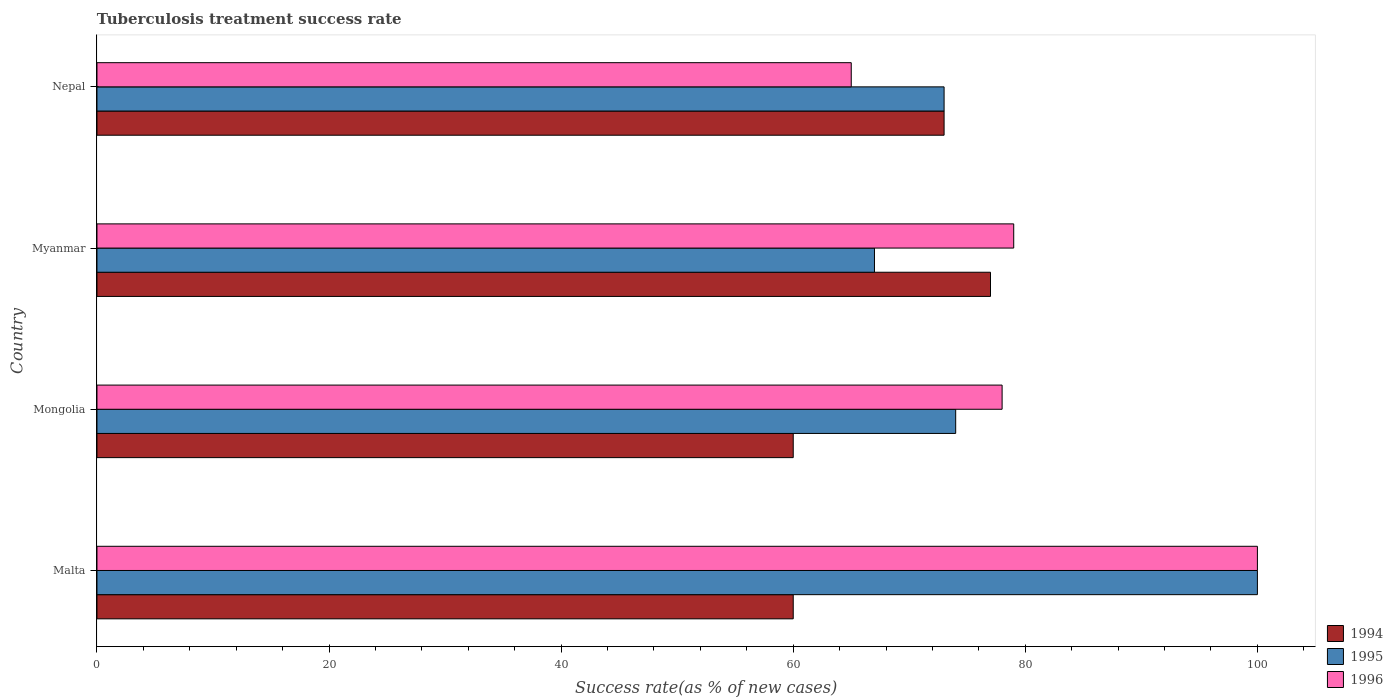How many groups of bars are there?
Give a very brief answer. 4. Are the number of bars per tick equal to the number of legend labels?
Your answer should be very brief. Yes. Are the number of bars on each tick of the Y-axis equal?
Your response must be concise. Yes. How many bars are there on the 1st tick from the bottom?
Offer a terse response. 3. What is the label of the 4th group of bars from the top?
Ensure brevity in your answer.  Malta. Across all countries, what is the minimum tuberculosis treatment success rate in 1995?
Your response must be concise. 67. In which country was the tuberculosis treatment success rate in 1994 maximum?
Ensure brevity in your answer.  Myanmar. In which country was the tuberculosis treatment success rate in 1996 minimum?
Your answer should be compact. Nepal. What is the total tuberculosis treatment success rate in 1996 in the graph?
Your answer should be compact. 322. What is the difference between the tuberculosis treatment success rate in 1995 in Myanmar and that in Nepal?
Keep it short and to the point. -6. What is the difference between the tuberculosis treatment success rate in 1996 in Mongolia and the tuberculosis treatment success rate in 1995 in Malta?
Offer a very short reply. -22. What is the average tuberculosis treatment success rate in 1995 per country?
Your response must be concise. 78.5. In how many countries, is the tuberculosis treatment success rate in 1996 greater than 80 %?
Offer a very short reply. 1. What is the ratio of the tuberculosis treatment success rate in 1995 in Mongolia to that in Nepal?
Offer a terse response. 1.01. In how many countries, is the tuberculosis treatment success rate in 1994 greater than the average tuberculosis treatment success rate in 1994 taken over all countries?
Offer a very short reply. 2. What does the 1st bar from the top in Mongolia represents?
Provide a succinct answer. 1996. How many bars are there?
Offer a very short reply. 12. Are all the bars in the graph horizontal?
Keep it short and to the point. Yes. Are the values on the major ticks of X-axis written in scientific E-notation?
Offer a terse response. No. Does the graph contain any zero values?
Offer a very short reply. No. Does the graph contain grids?
Your answer should be very brief. No. What is the title of the graph?
Provide a succinct answer. Tuberculosis treatment success rate. What is the label or title of the X-axis?
Your answer should be very brief. Success rate(as % of new cases). What is the Success rate(as % of new cases) of 1994 in Malta?
Give a very brief answer. 60. What is the Success rate(as % of new cases) of 1996 in Malta?
Ensure brevity in your answer.  100. What is the Success rate(as % of new cases) of 1994 in Mongolia?
Provide a short and direct response. 60. What is the Success rate(as % of new cases) in 1995 in Mongolia?
Your answer should be compact. 74. What is the Success rate(as % of new cases) of 1994 in Myanmar?
Your answer should be compact. 77. What is the Success rate(as % of new cases) of 1996 in Myanmar?
Your response must be concise. 79. What is the Success rate(as % of new cases) of 1995 in Nepal?
Give a very brief answer. 73. What is the Success rate(as % of new cases) of 1996 in Nepal?
Offer a very short reply. 65. Across all countries, what is the maximum Success rate(as % of new cases) of 1994?
Offer a very short reply. 77. Across all countries, what is the maximum Success rate(as % of new cases) of 1996?
Your answer should be compact. 100. Across all countries, what is the minimum Success rate(as % of new cases) of 1994?
Ensure brevity in your answer.  60. Across all countries, what is the minimum Success rate(as % of new cases) in 1996?
Provide a succinct answer. 65. What is the total Success rate(as % of new cases) of 1994 in the graph?
Provide a succinct answer. 270. What is the total Success rate(as % of new cases) of 1995 in the graph?
Give a very brief answer. 314. What is the total Success rate(as % of new cases) of 1996 in the graph?
Your answer should be compact. 322. What is the difference between the Success rate(as % of new cases) in 1994 in Malta and that in Mongolia?
Your answer should be very brief. 0. What is the difference between the Success rate(as % of new cases) of 1995 in Malta and that in Mongolia?
Provide a succinct answer. 26. What is the difference between the Success rate(as % of new cases) of 1994 in Malta and that in Myanmar?
Offer a very short reply. -17. What is the difference between the Success rate(as % of new cases) in 1995 in Malta and that in Myanmar?
Your answer should be very brief. 33. What is the difference between the Success rate(as % of new cases) of 1994 in Malta and that in Nepal?
Offer a terse response. -13. What is the difference between the Success rate(as % of new cases) in 1994 in Mongolia and that in Myanmar?
Your answer should be very brief. -17. What is the difference between the Success rate(as % of new cases) in 1995 in Mongolia and that in Myanmar?
Provide a short and direct response. 7. What is the difference between the Success rate(as % of new cases) in 1996 in Mongolia and that in Nepal?
Your response must be concise. 13. What is the difference between the Success rate(as % of new cases) of 1994 in Myanmar and that in Nepal?
Make the answer very short. 4. What is the difference between the Success rate(as % of new cases) in 1996 in Myanmar and that in Nepal?
Your answer should be compact. 14. What is the difference between the Success rate(as % of new cases) in 1994 in Malta and the Success rate(as % of new cases) in 1996 in Mongolia?
Your response must be concise. -18. What is the difference between the Success rate(as % of new cases) in 1994 in Malta and the Success rate(as % of new cases) in 1996 in Myanmar?
Ensure brevity in your answer.  -19. What is the difference between the Success rate(as % of new cases) in 1995 in Malta and the Success rate(as % of new cases) in 1996 in Myanmar?
Provide a short and direct response. 21. What is the difference between the Success rate(as % of new cases) in 1994 in Malta and the Success rate(as % of new cases) in 1996 in Nepal?
Ensure brevity in your answer.  -5. What is the difference between the Success rate(as % of new cases) of 1995 in Malta and the Success rate(as % of new cases) of 1996 in Nepal?
Offer a terse response. 35. What is the difference between the Success rate(as % of new cases) in 1994 in Mongolia and the Success rate(as % of new cases) in 1996 in Myanmar?
Keep it short and to the point. -19. What is the difference between the Success rate(as % of new cases) of 1994 in Mongolia and the Success rate(as % of new cases) of 1995 in Nepal?
Give a very brief answer. -13. What is the difference between the Success rate(as % of new cases) of 1995 in Mongolia and the Success rate(as % of new cases) of 1996 in Nepal?
Provide a succinct answer. 9. What is the difference between the Success rate(as % of new cases) in 1995 in Myanmar and the Success rate(as % of new cases) in 1996 in Nepal?
Your answer should be compact. 2. What is the average Success rate(as % of new cases) in 1994 per country?
Your answer should be very brief. 67.5. What is the average Success rate(as % of new cases) in 1995 per country?
Offer a terse response. 78.5. What is the average Success rate(as % of new cases) of 1996 per country?
Your response must be concise. 80.5. What is the difference between the Success rate(as % of new cases) in 1994 and Success rate(as % of new cases) in 1995 in Malta?
Offer a terse response. -40. What is the difference between the Success rate(as % of new cases) of 1994 and Success rate(as % of new cases) of 1996 in Malta?
Your answer should be compact. -40. What is the difference between the Success rate(as % of new cases) of 1995 and Success rate(as % of new cases) of 1996 in Malta?
Keep it short and to the point. 0. What is the difference between the Success rate(as % of new cases) of 1994 and Success rate(as % of new cases) of 1995 in Mongolia?
Make the answer very short. -14. What is the difference between the Success rate(as % of new cases) of 1995 and Success rate(as % of new cases) of 1996 in Mongolia?
Offer a very short reply. -4. What is the difference between the Success rate(as % of new cases) of 1994 and Success rate(as % of new cases) of 1995 in Myanmar?
Give a very brief answer. 10. What is the difference between the Success rate(as % of new cases) in 1994 and Success rate(as % of new cases) in 1996 in Myanmar?
Keep it short and to the point. -2. What is the difference between the Success rate(as % of new cases) in 1994 and Success rate(as % of new cases) in 1995 in Nepal?
Provide a short and direct response. 0. What is the difference between the Success rate(as % of new cases) of 1994 and Success rate(as % of new cases) of 1996 in Nepal?
Provide a short and direct response. 8. What is the difference between the Success rate(as % of new cases) in 1995 and Success rate(as % of new cases) in 1996 in Nepal?
Ensure brevity in your answer.  8. What is the ratio of the Success rate(as % of new cases) in 1995 in Malta to that in Mongolia?
Provide a short and direct response. 1.35. What is the ratio of the Success rate(as % of new cases) in 1996 in Malta to that in Mongolia?
Provide a short and direct response. 1.28. What is the ratio of the Success rate(as % of new cases) of 1994 in Malta to that in Myanmar?
Offer a terse response. 0.78. What is the ratio of the Success rate(as % of new cases) in 1995 in Malta to that in Myanmar?
Your answer should be compact. 1.49. What is the ratio of the Success rate(as % of new cases) in 1996 in Malta to that in Myanmar?
Offer a terse response. 1.27. What is the ratio of the Success rate(as % of new cases) in 1994 in Malta to that in Nepal?
Your response must be concise. 0.82. What is the ratio of the Success rate(as % of new cases) of 1995 in Malta to that in Nepal?
Offer a terse response. 1.37. What is the ratio of the Success rate(as % of new cases) in 1996 in Malta to that in Nepal?
Provide a succinct answer. 1.54. What is the ratio of the Success rate(as % of new cases) of 1994 in Mongolia to that in Myanmar?
Ensure brevity in your answer.  0.78. What is the ratio of the Success rate(as % of new cases) in 1995 in Mongolia to that in Myanmar?
Your response must be concise. 1.1. What is the ratio of the Success rate(as % of new cases) in 1996 in Mongolia to that in Myanmar?
Make the answer very short. 0.99. What is the ratio of the Success rate(as % of new cases) in 1994 in Mongolia to that in Nepal?
Offer a terse response. 0.82. What is the ratio of the Success rate(as % of new cases) of 1995 in Mongolia to that in Nepal?
Provide a short and direct response. 1.01. What is the ratio of the Success rate(as % of new cases) of 1996 in Mongolia to that in Nepal?
Ensure brevity in your answer.  1.2. What is the ratio of the Success rate(as % of new cases) in 1994 in Myanmar to that in Nepal?
Provide a short and direct response. 1.05. What is the ratio of the Success rate(as % of new cases) in 1995 in Myanmar to that in Nepal?
Offer a very short reply. 0.92. What is the ratio of the Success rate(as % of new cases) in 1996 in Myanmar to that in Nepal?
Provide a succinct answer. 1.22. What is the difference between the highest and the second highest Success rate(as % of new cases) of 1995?
Your answer should be very brief. 26. What is the difference between the highest and the lowest Success rate(as % of new cases) in 1995?
Ensure brevity in your answer.  33. 